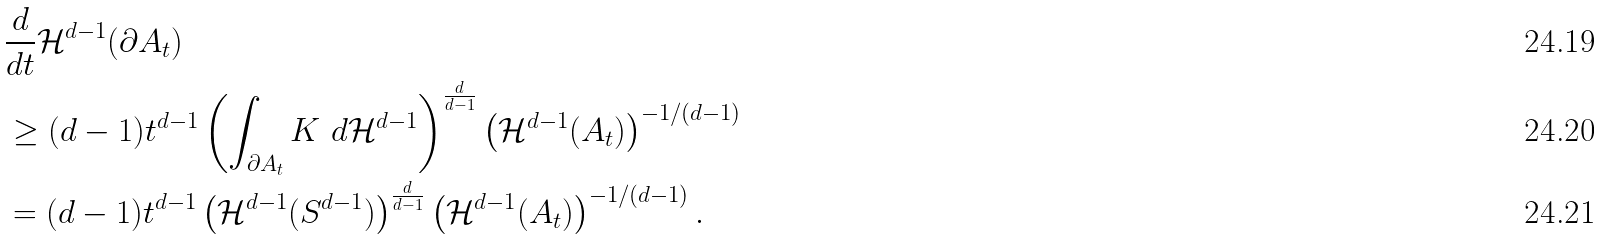<formula> <loc_0><loc_0><loc_500><loc_500>& \frac { d } { d t } \mathcal { H } ^ { d - 1 } ( \partial A _ { t } ) \\ & \geq ( d - 1 ) t ^ { d - 1 } \left ( \int _ { \partial A _ { t } } K \ d \mathcal { H } ^ { d - 1 } \right ) ^ { \frac { d } { d - 1 } } \left ( \mathcal { H } ^ { d - 1 } ( A _ { t } ) \right ) ^ { - 1 / ( d - 1 ) } \\ & = ( d - 1 ) t ^ { d - 1 } \left ( \mathcal { H } ^ { d - 1 } ( S ^ { d - 1 } ) \right ) ^ { \frac { d } { d - 1 } } \left ( \mathcal { H } ^ { d - 1 } ( A _ { t } ) \right ) ^ { - 1 / ( d - 1 ) } .</formula> 